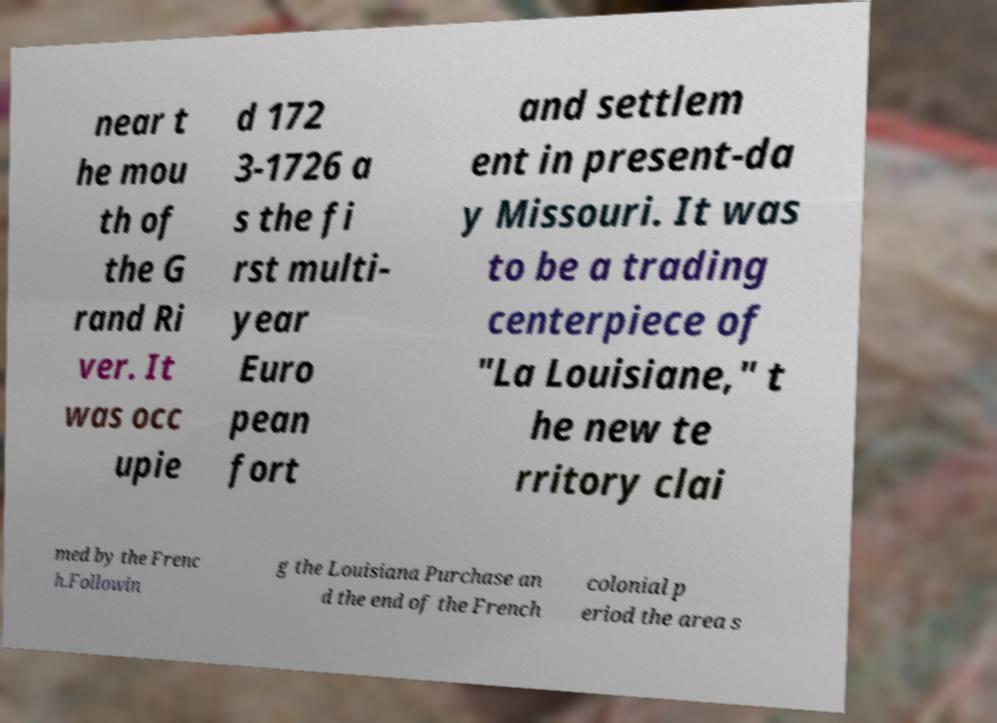For documentation purposes, I need the text within this image transcribed. Could you provide that? near t he mou th of the G rand Ri ver. It was occ upie d 172 3-1726 a s the fi rst multi- year Euro pean fort and settlem ent in present-da y Missouri. It was to be a trading centerpiece of "La Louisiane," t he new te rritory clai med by the Frenc h.Followin g the Louisiana Purchase an d the end of the French colonial p eriod the area s 